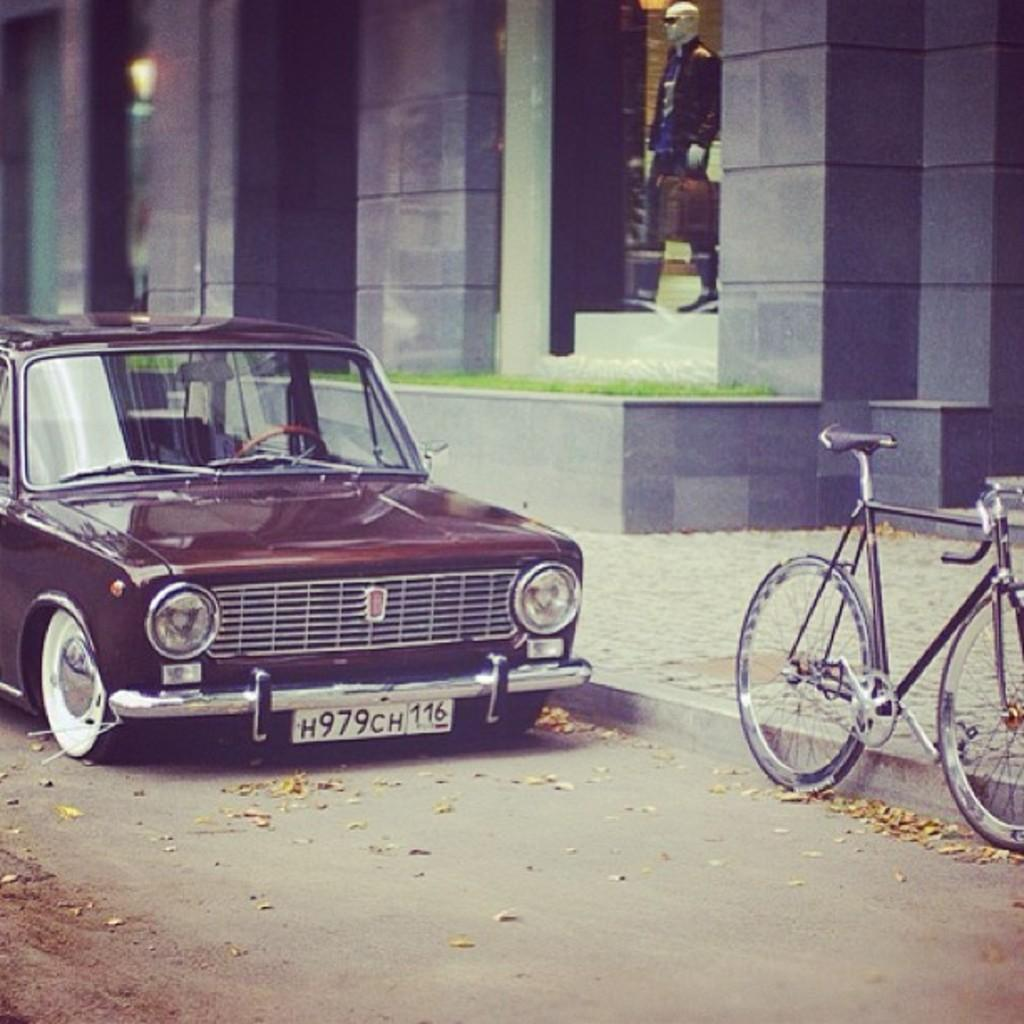What type of vehicle is on the left side of the image? There is a car in dark red color on the left side of the image. What is on the right side of the image? There is a cycle on the right side of the image. Where is the cycle located? The cycle is on the road. What structure can be seen in the image? There is a building in the image. What is inside the building? There is a doll of a man in the showcase of the building. What type of error can be seen in the image? There is no error present in the image. What rule is being followed by the car and the cycle in the image? The provided facts do not mention any rules being followed by the car or the cycle in the image. 